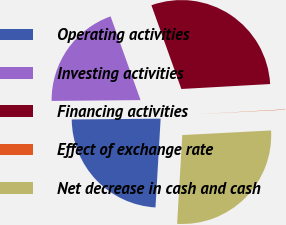Convert chart to OTSL. <chart><loc_0><loc_0><loc_500><loc_500><pie_chart><fcel>Operating activities<fcel>Investing activities<fcel>Financing activities<fcel>Effect of exchange rate<fcel>Net decrease in cash and cash<nl><fcel>23.93%<fcel>19.68%<fcel>29.58%<fcel>0.06%<fcel>26.75%<nl></chart> 